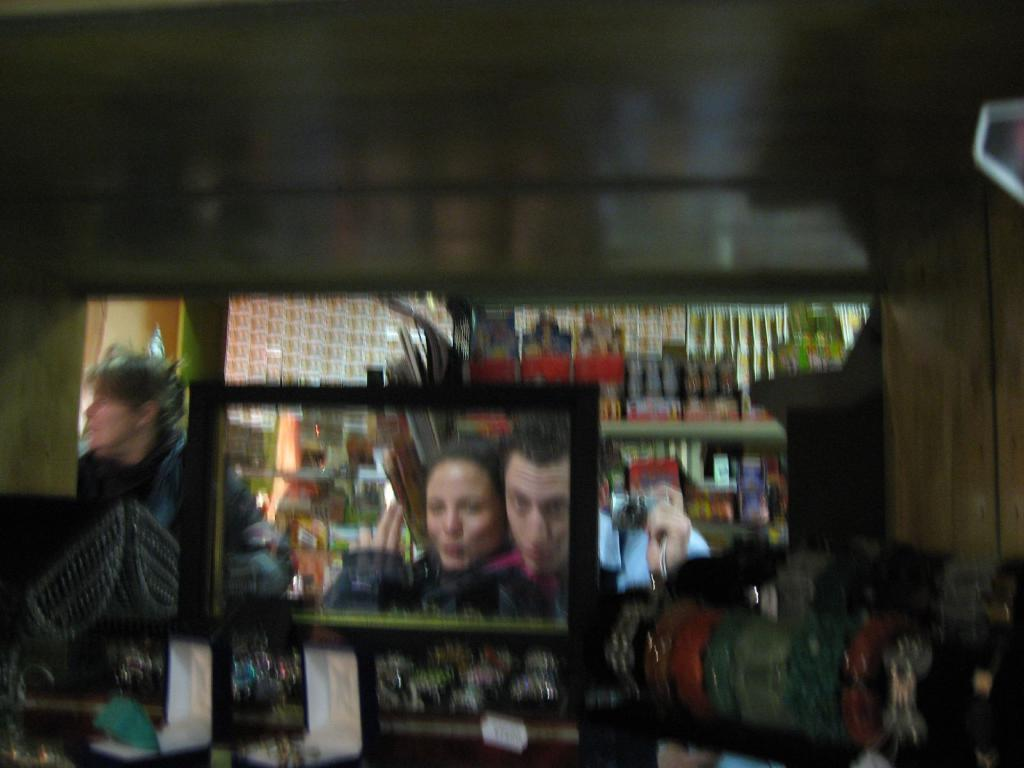Can you describe the image in detail? Unfortunately, the image is blurry, and it is difficult to make out any specific elements or objects. Reasoning: Since the image is blurry and the presence of any elements cannot be confirmed, we cannot create a conversation based on specific facts. Instead, we acknowledge the blurriness of the image and avoid making assumptions about what might be present. Absurd Question/Answer: How many chairs are visible in the image? There are no chairs visible in the image, as it is blurry and the presence of any elements cannot be confirmed. 